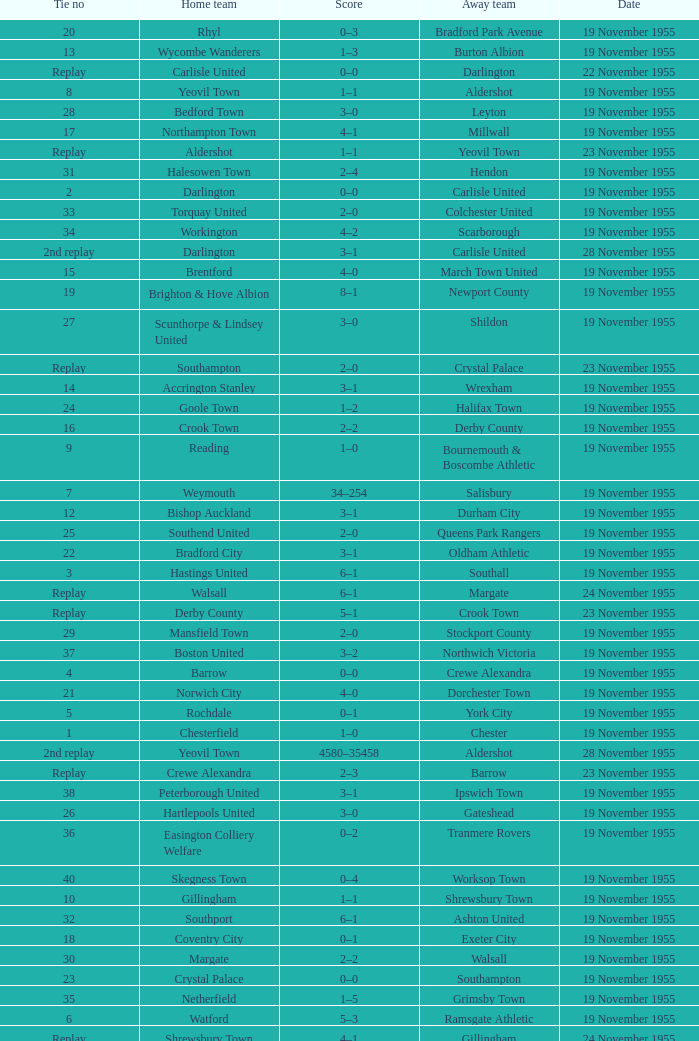Parse the table in full. {'header': ['Tie no', 'Home team', 'Score', 'Away team', 'Date'], 'rows': [['20', 'Rhyl', '0–3', 'Bradford Park Avenue', '19 November 1955'], ['13', 'Wycombe Wanderers', '1–3', 'Burton Albion', '19 November 1955'], ['Replay', 'Carlisle United', '0–0', 'Darlington', '22 November 1955'], ['8', 'Yeovil Town', '1–1', 'Aldershot', '19 November 1955'], ['28', 'Bedford Town', '3–0', 'Leyton', '19 November 1955'], ['17', 'Northampton Town', '4–1', 'Millwall', '19 November 1955'], ['Replay', 'Aldershot', '1–1', 'Yeovil Town', '23 November 1955'], ['31', 'Halesowen Town', '2–4', 'Hendon', '19 November 1955'], ['2', 'Darlington', '0–0', 'Carlisle United', '19 November 1955'], ['33', 'Torquay United', '2–0', 'Colchester United', '19 November 1955'], ['34', 'Workington', '4–2', 'Scarborough', '19 November 1955'], ['2nd replay', 'Darlington', '3–1', 'Carlisle United', '28 November 1955'], ['15', 'Brentford', '4–0', 'March Town United', '19 November 1955'], ['19', 'Brighton & Hove Albion', '8–1', 'Newport County', '19 November 1955'], ['27', 'Scunthorpe & Lindsey United', '3–0', 'Shildon', '19 November 1955'], ['Replay', 'Southampton', '2–0', 'Crystal Palace', '23 November 1955'], ['14', 'Accrington Stanley', '3–1', 'Wrexham', '19 November 1955'], ['24', 'Goole Town', '1–2', 'Halifax Town', '19 November 1955'], ['16', 'Crook Town', '2–2', 'Derby County', '19 November 1955'], ['9', 'Reading', '1–0', 'Bournemouth & Boscombe Athletic', '19 November 1955'], ['7', 'Weymouth', '34–254', 'Salisbury', '19 November 1955'], ['12', 'Bishop Auckland', '3–1', 'Durham City', '19 November 1955'], ['25', 'Southend United', '2–0', 'Queens Park Rangers', '19 November 1955'], ['22', 'Bradford City', '3–1', 'Oldham Athletic', '19 November 1955'], ['3', 'Hastings United', '6–1', 'Southall', '19 November 1955'], ['Replay', 'Walsall', '6–1', 'Margate', '24 November 1955'], ['Replay', 'Derby County', '5–1', 'Crook Town', '23 November 1955'], ['29', 'Mansfield Town', '2–0', 'Stockport County', '19 November 1955'], ['37', 'Boston United', '3–2', 'Northwich Victoria', '19 November 1955'], ['4', 'Barrow', '0–0', 'Crewe Alexandra', '19 November 1955'], ['21', 'Norwich City', '4–0', 'Dorchester Town', '19 November 1955'], ['5', 'Rochdale', '0–1', 'York City', '19 November 1955'], ['1', 'Chesterfield', '1–0', 'Chester', '19 November 1955'], ['2nd replay', 'Yeovil Town', '4580–35458', 'Aldershot', '28 November 1955'], ['Replay', 'Crewe Alexandra', '2–3', 'Barrow', '23 November 1955'], ['38', 'Peterborough United', '3–1', 'Ipswich Town', '19 November 1955'], ['26', 'Hartlepools United', '3–0', 'Gateshead', '19 November 1955'], ['36', 'Easington Colliery Welfare', '0–2', 'Tranmere Rovers', '19 November 1955'], ['40', 'Skegness Town', '0–4', 'Worksop Town', '19 November 1955'], ['10', 'Gillingham', '1–1', 'Shrewsbury Town', '19 November 1955'], ['32', 'Southport', '6–1', 'Ashton United', '19 November 1955'], ['18', 'Coventry City', '0–1', 'Exeter City', '19 November 1955'], ['30', 'Margate', '2–2', 'Walsall', '19 November 1955'], ['23', 'Crystal Palace', '0–0', 'Southampton', '19 November 1955'], ['35', 'Netherfield', '1–5', 'Grimsby Town', '19 November 1955'], ['6', 'Watford', '5–3', 'Ramsgate Athletic', '19 November 1955'], ['Replay', 'Shrewsbury Town', '4–1', 'Gillingham', '24 November 1955'], ['11', 'Swindon Town', '4–0', 'Hereford United', '19 November 1955'], ['39', 'Leyton Orient', '7–1', 'Lovells Athletic', '19 November 1955']]} What is the date of tie no. 34? 19 November 1955. 